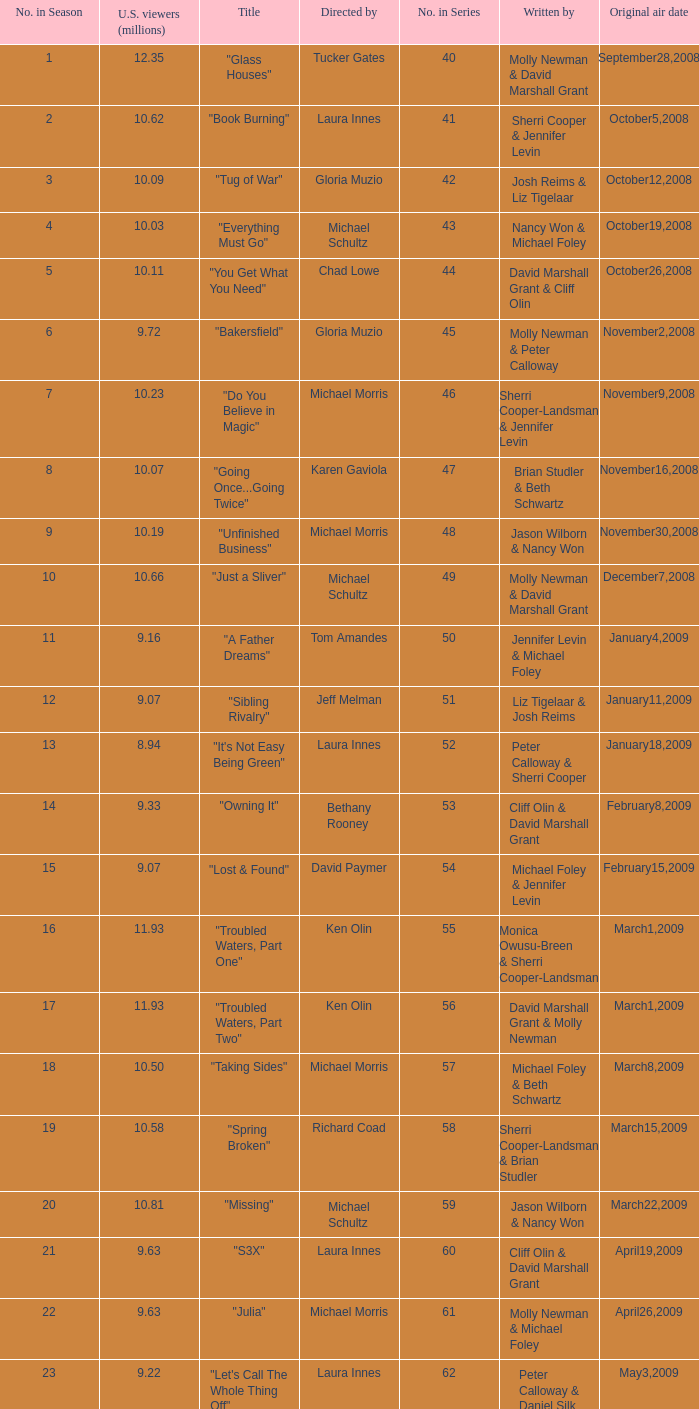Who wrote the episode whose director is Karen Gaviola? Brian Studler & Beth Schwartz. 